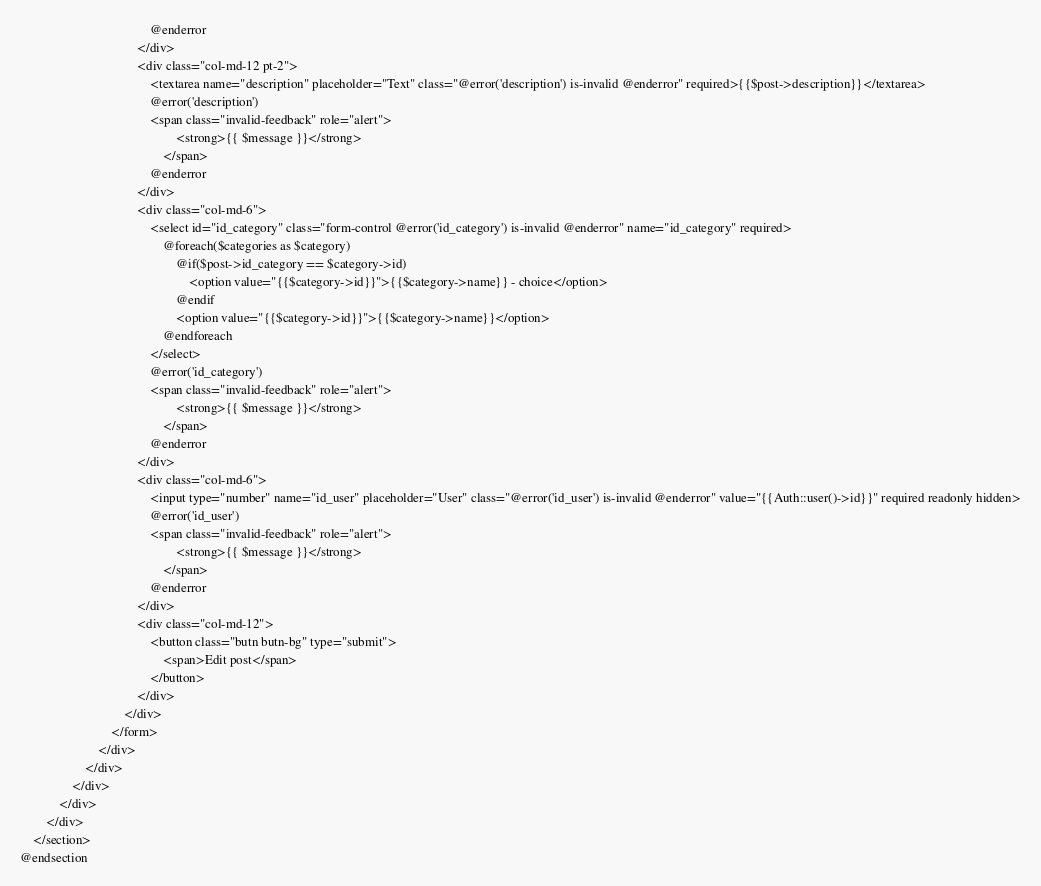Convert code to text. <code><loc_0><loc_0><loc_500><loc_500><_PHP_>                                        @enderror
                                    </div>
                                    <div class="col-md-12 pt-2">
                                        <textarea name="description" placeholder="Text" class="@error('description') is-invalid @enderror" required>{{$post->description}}</textarea>
                                        @error('description')
                                        <span class="invalid-feedback" role="alert">
                                                <strong>{{ $message }}</strong>
                                            </span>
                                        @enderror
                                    </div>
                                    <div class="col-md-6">
                                        <select id="id_category" class="form-control @error('id_category') is-invalid @enderror" name="id_category" required>
                                            @foreach($categories as $category)
                                                @if($post->id_category == $category->id)
                                                    <option value="{{$category->id}}">{{$category->name}} - choice</option>
                                                @endif
                                                <option value="{{$category->id}}">{{$category->name}}</option>
                                            @endforeach
                                        </select>
                                        @error('id_category')
                                        <span class="invalid-feedback" role="alert">
                                                <strong>{{ $message }}</strong>
                                            </span>
                                        @enderror
                                    </div>
                                    <div class="col-md-6">
                                        <input type="number" name="id_user" placeholder="User" class="@error('id_user') is-invalid @enderror" value="{{Auth::user()->id}}" required readonly hidden>
                                        @error('id_user')
                                        <span class="invalid-feedback" role="alert">
                                                <strong>{{ $message }}</strong>
                                            </span>
                                        @enderror
                                    </div>
                                    <div class="col-md-12">
                                        <button class="butn butn-bg" type="submit">
                                            <span>Edit post</span>
                                        </button>
                                    </div>
                                </div>
                            </form>
                        </div>
                    </div>
                </div>
            </div>
        </div>
    </section>
@endsection
</code> 